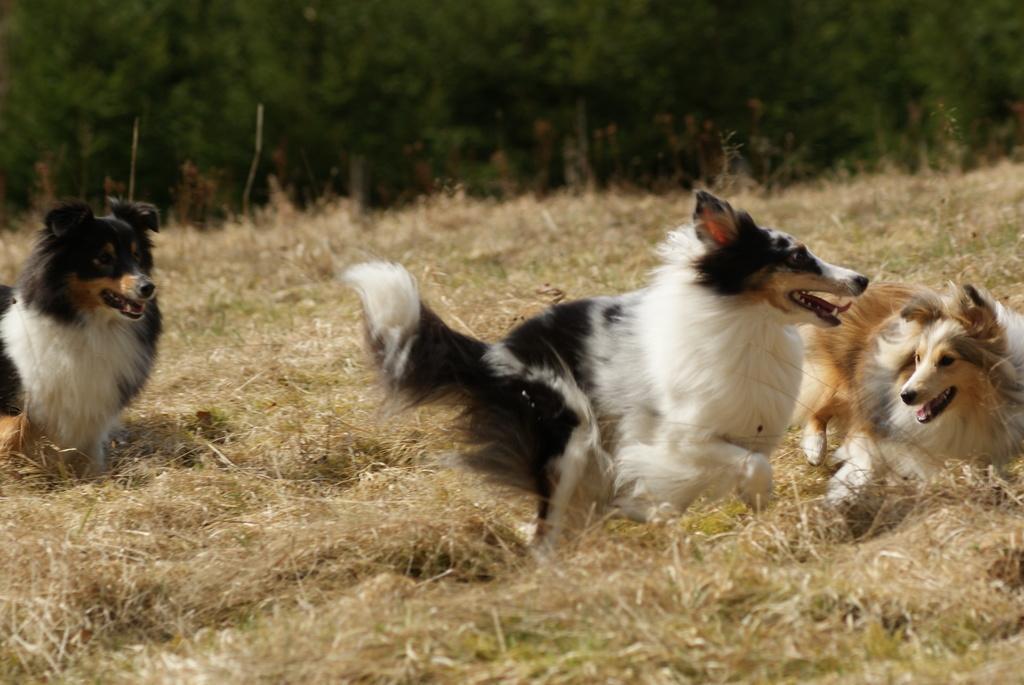Could you give a brief overview of what you see in this image? In this image there are three dogs on a grassland, in the background there are trees and it is blurred. 